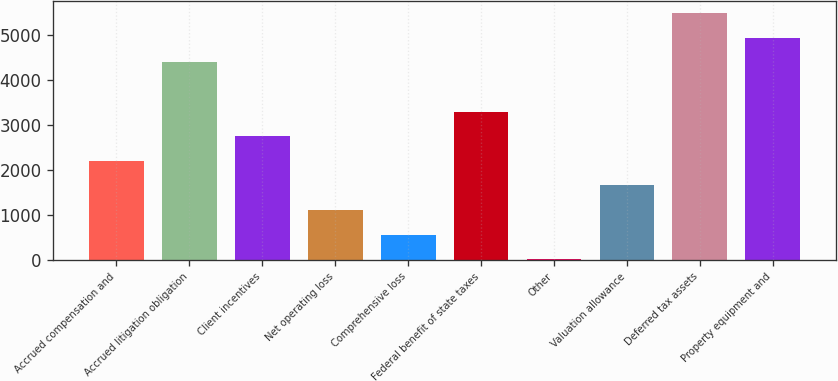Convert chart. <chart><loc_0><loc_0><loc_500><loc_500><bar_chart><fcel>Accrued compensation and<fcel>Accrued litigation obligation<fcel>Client incentives<fcel>Net operating loss<fcel>Comprehensive loss<fcel>Federal benefit of state taxes<fcel>Other<fcel>Valuation allowance<fcel>Deferred tax assets<fcel>Property equipment and<nl><fcel>2196<fcel>4386<fcel>2743.5<fcel>1101<fcel>553.5<fcel>3291<fcel>6<fcel>1648.5<fcel>5481<fcel>4933.5<nl></chart> 